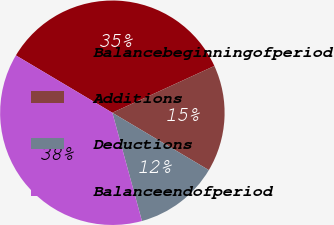Convert chart to OTSL. <chart><loc_0><loc_0><loc_500><loc_500><pie_chart><fcel>Balancebeginningofperiod<fcel>Additions<fcel>Deductions<fcel>Balanceendofperiod<nl><fcel>34.62%<fcel>15.38%<fcel>12.22%<fcel>37.78%<nl></chart> 